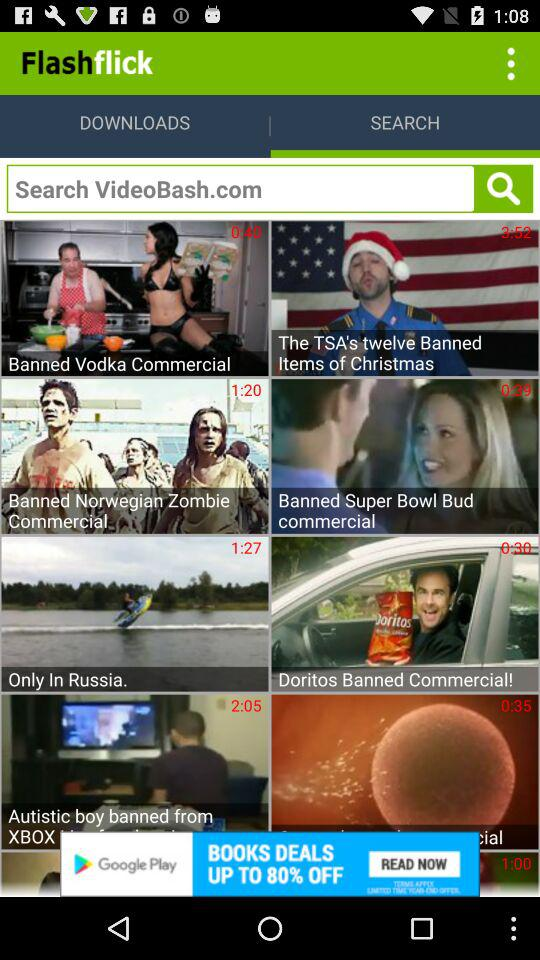Which option is selected? The selected option is "SEARCH". 